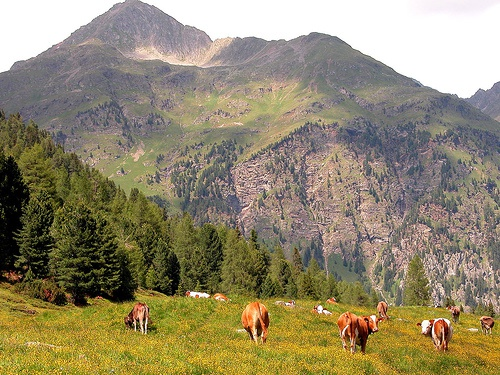Describe the objects in this image and their specific colors. I can see cow in white, maroon, red, black, and orange tones, cow in white, orange, maroon, red, and brown tones, cow in white, maroon, and brown tones, cow in white, black, maroon, and tan tones, and cow in white, maroon, olive, gray, and black tones in this image. 